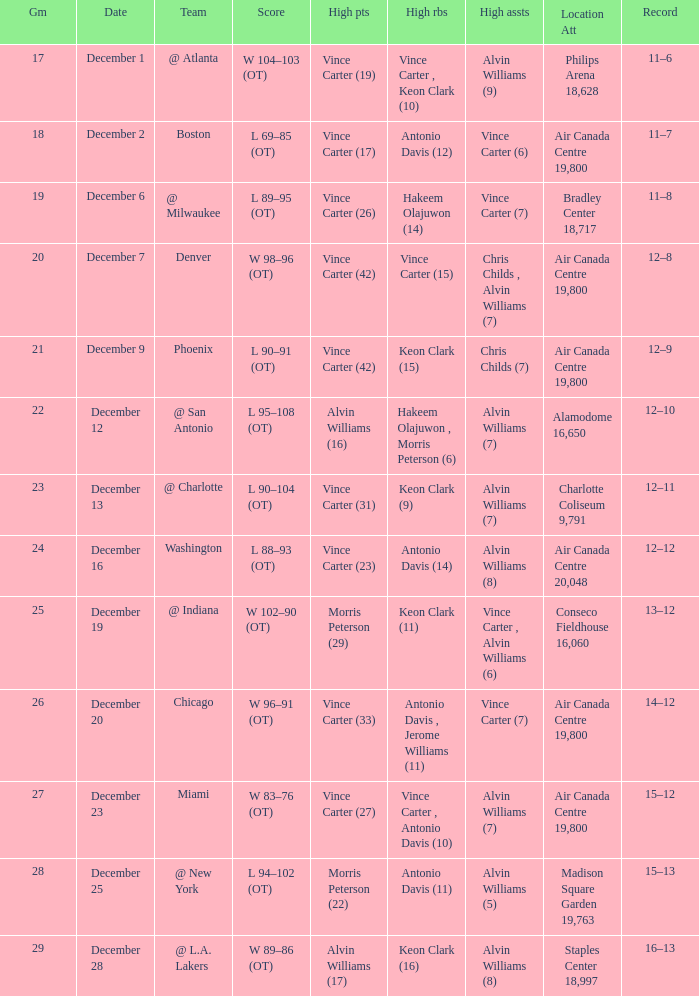Who scored the most points against Washington? Vince Carter (23). 